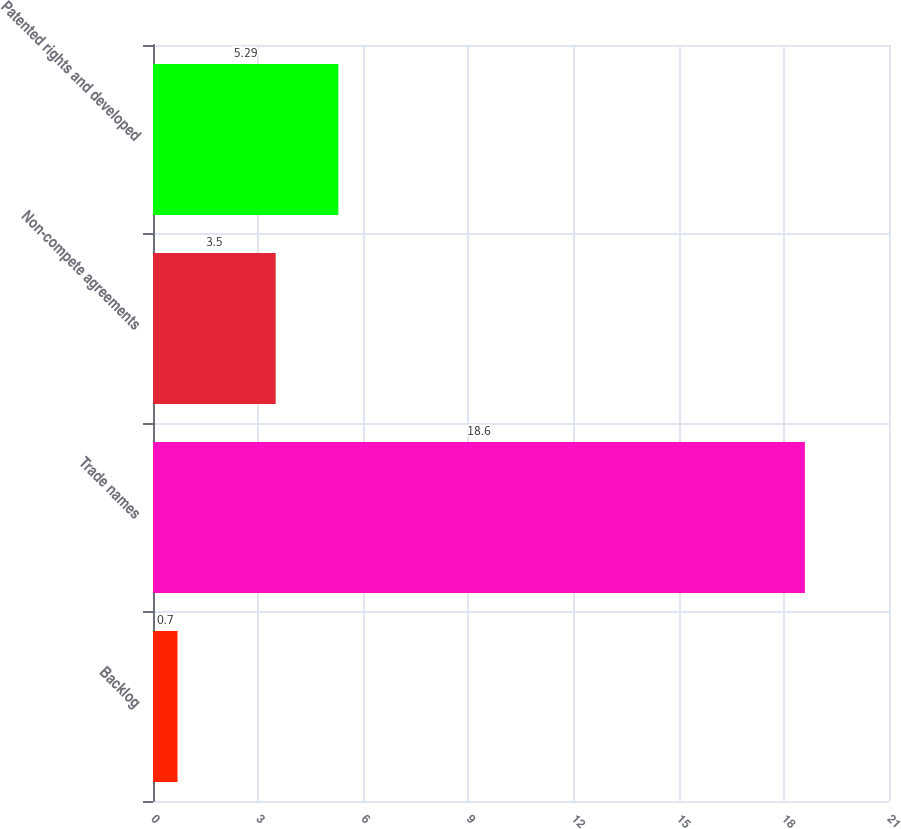Convert chart to OTSL. <chart><loc_0><loc_0><loc_500><loc_500><bar_chart><fcel>Backlog<fcel>Trade names<fcel>Non-compete agreements<fcel>Patented rights and developed<nl><fcel>0.7<fcel>18.6<fcel>3.5<fcel>5.29<nl></chart> 